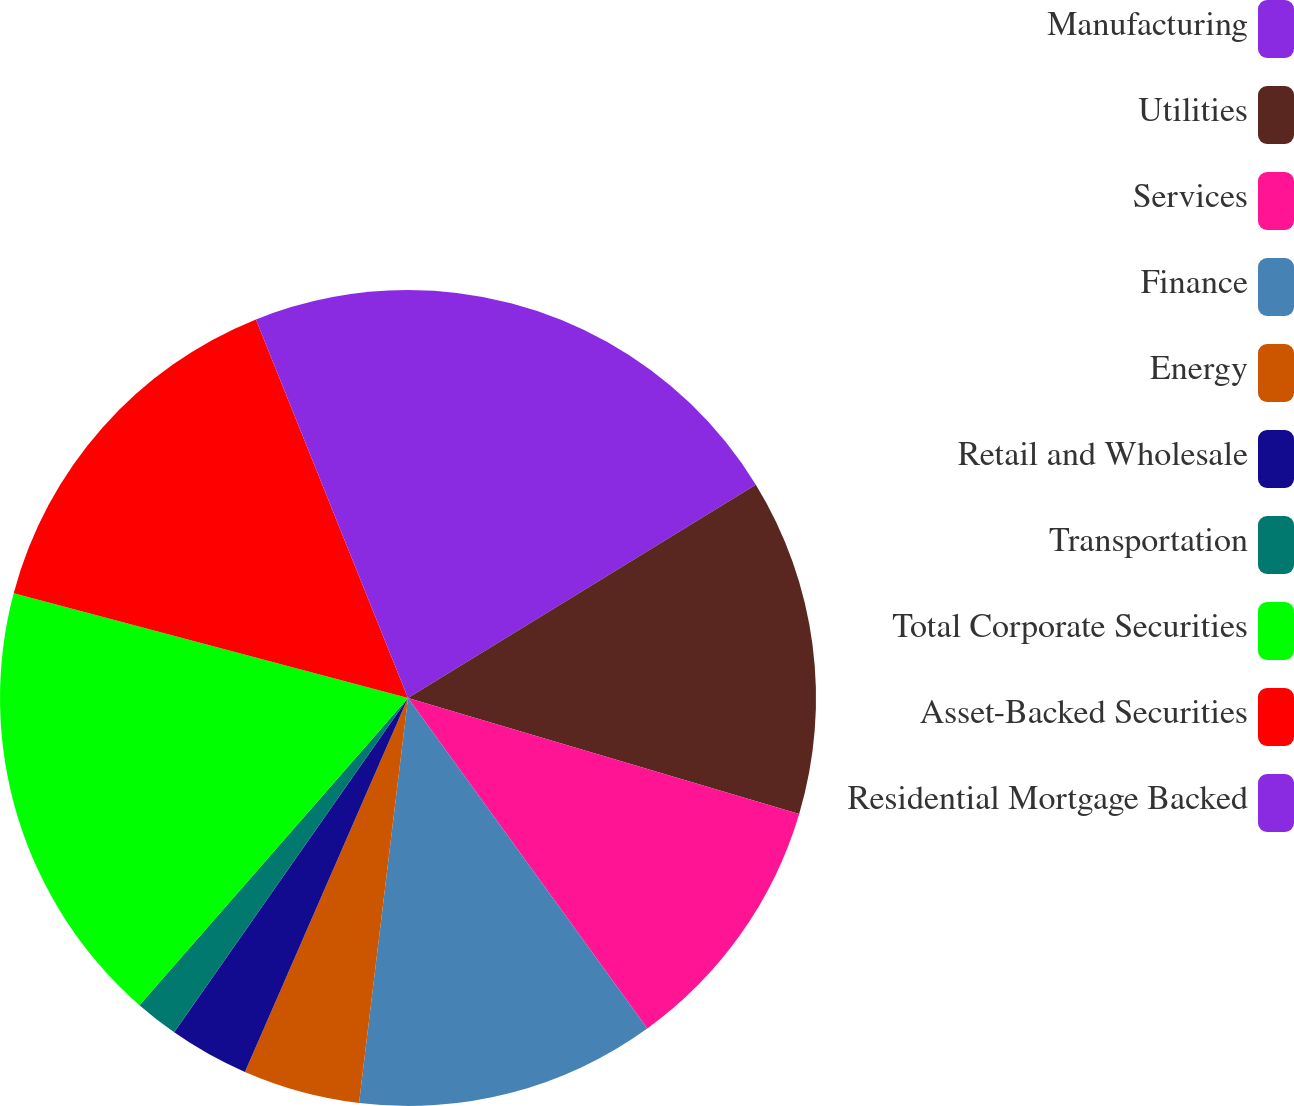<chart> <loc_0><loc_0><loc_500><loc_500><pie_chart><fcel>Manufacturing<fcel>Utilities<fcel>Services<fcel>Finance<fcel>Energy<fcel>Retail and Wholesale<fcel>Transportation<fcel>Total Corporate Securities<fcel>Asset-Backed Securities<fcel>Residential Mortgage Backed<nl><fcel>16.25%<fcel>13.34%<fcel>10.44%<fcel>11.89%<fcel>4.63%<fcel>3.17%<fcel>1.72%<fcel>17.7%<fcel>14.79%<fcel>6.08%<nl></chart> 